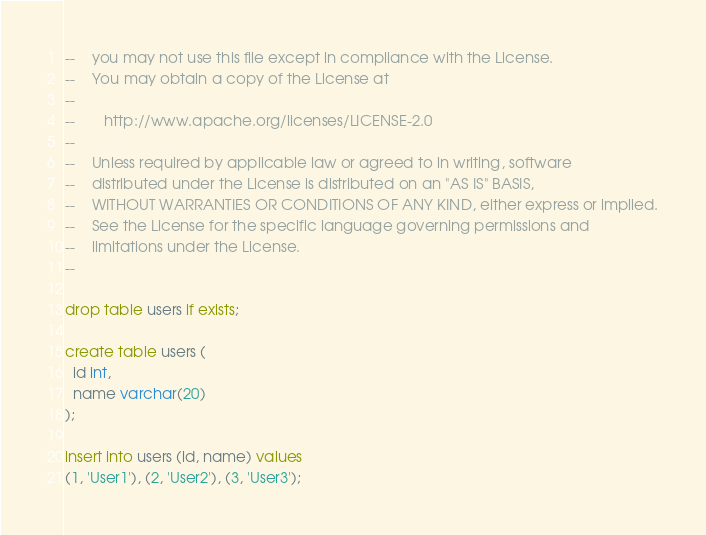Convert code to text. <code><loc_0><loc_0><loc_500><loc_500><_SQL_>--    you may not use this file except in compliance with the License.
--    You may obtain a copy of the License at
--
--       http://www.apache.org/licenses/LICENSE-2.0
--
--    Unless required by applicable law or agreed to in writing, software
--    distributed under the License is distributed on an "AS IS" BASIS,
--    WITHOUT WARRANTIES OR CONDITIONS OF ANY KIND, either express or implied.
--    See the License for the specific language governing permissions and
--    limitations under the License.
--

drop table users if exists;

create table users (
  id int,
  name varchar(20)
);

insert into users (id, name) values
(1, 'User1'), (2, 'User2'), (3, 'User3');
</code> 